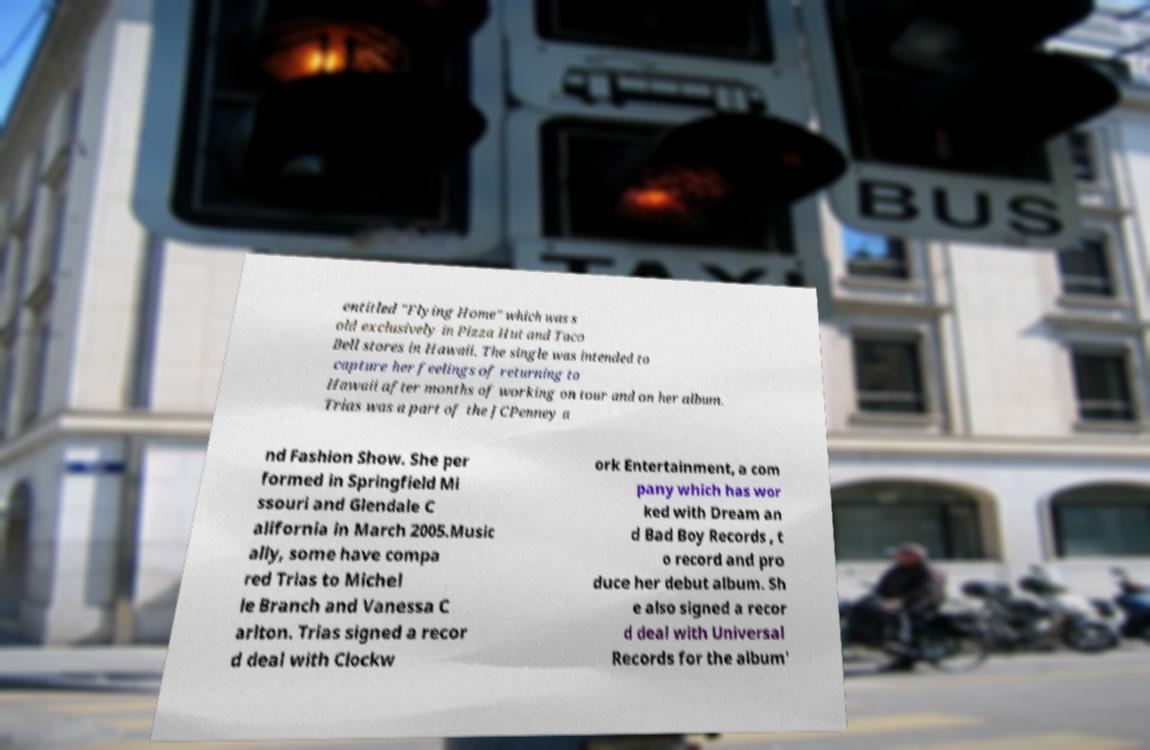For documentation purposes, I need the text within this image transcribed. Could you provide that? entitled "Flying Home" which was s old exclusively in Pizza Hut and Taco Bell stores in Hawaii. The single was intended to capture her feelings of returning to Hawaii after months of working on tour and on her album. Trias was a part of the JCPenney a nd Fashion Show. She per formed in Springfield Mi ssouri and Glendale C alifornia in March 2005.Music ally, some have compa red Trias to Michel le Branch and Vanessa C arlton. Trias signed a recor d deal with Clockw ork Entertainment, a com pany which has wor ked with Dream an d Bad Boy Records , t o record and pro duce her debut album. Sh e also signed a recor d deal with Universal Records for the album' 